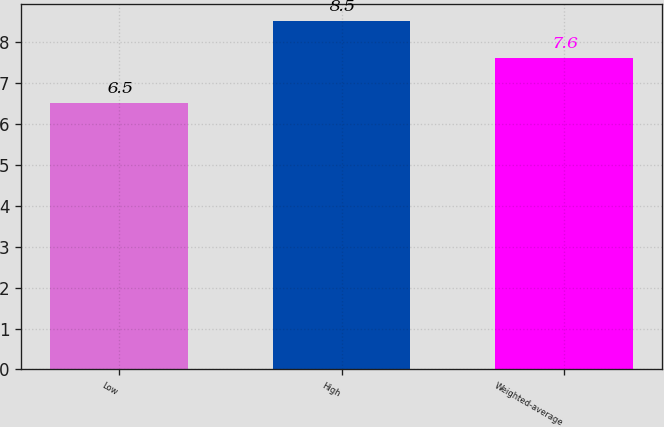Convert chart to OTSL. <chart><loc_0><loc_0><loc_500><loc_500><bar_chart><fcel>Low<fcel>High<fcel>Weighted-average<nl><fcel>6.5<fcel>8.5<fcel>7.6<nl></chart> 